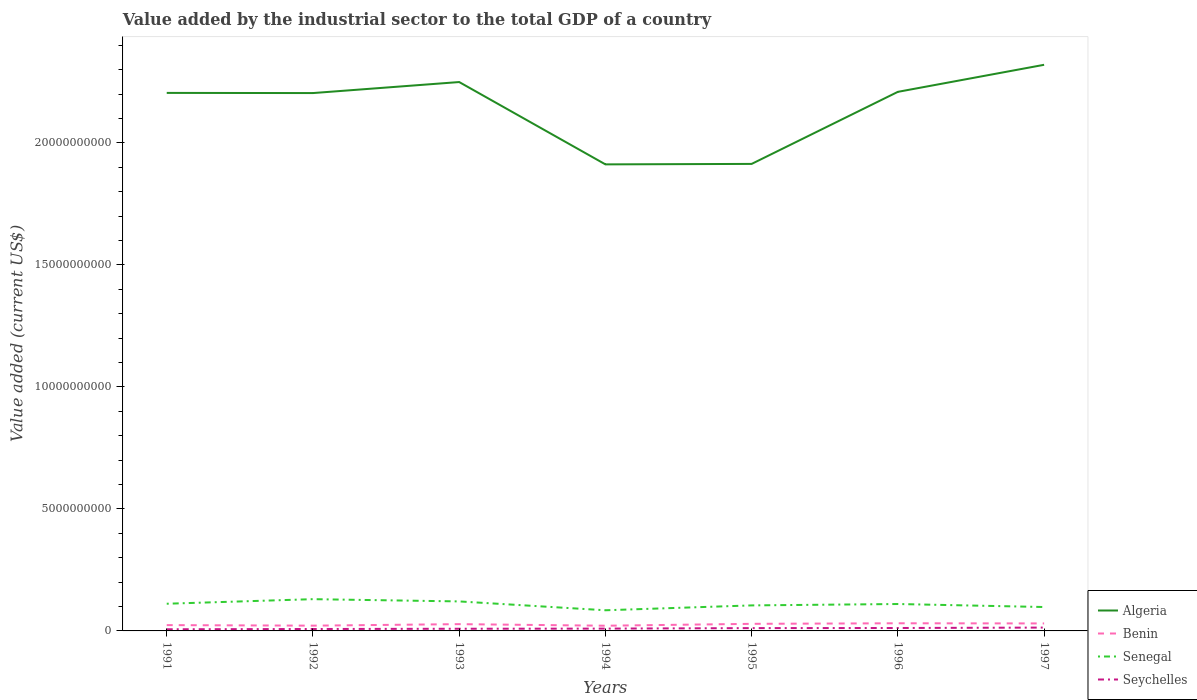Across all years, what is the maximum value added by the industrial sector to the total GDP in Seychelles?
Make the answer very short. 6.77e+07. In which year was the value added by the industrial sector to the total GDP in Senegal maximum?
Make the answer very short. 1994. What is the total value added by the industrial sector to the total GDP in Algeria in the graph?
Provide a succinct answer. 2.90e+09. What is the difference between the highest and the second highest value added by the industrial sector to the total GDP in Senegal?
Offer a terse response. 4.55e+08. What is the difference between the highest and the lowest value added by the industrial sector to the total GDP in Senegal?
Your answer should be compact. 4. What is the difference between two consecutive major ticks on the Y-axis?
Your answer should be compact. 5.00e+09. Are the values on the major ticks of Y-axis written in scientific E-notation?
Ensure brevity in your answer.  No. Does the graph contain grids?
Your answer should be compact. No. What is the title of the graph?
Your answer should be compact. Value added by the industrial sector to the total GDP of a country. What is the label or title of the X-axis?
Make the answer very short. Years. What is the label or title of the Y-axis?
Your answer should be compact. Value added (current US$). What is the Value added (current US$) of Algeria in 1991?
Your answer should be compact. 2.20e+1. What is the Value added (current US$) of Benin in 1991?
Give a very brief answer. 2.38e+08. What is the Value added (current US$) of Senegal in 1991?
Your answer should be compact. 1.11e+09. What is the Value added (current US$) of Seychelles in 1991?
Give a very brief answer. 6.77e+07. What is the Value added (current US$) in Algeria in 1992?
Provide a succinct answer. 2.20e+1. What is the Value added (current US$) in Benin in 1992?
Ensure brevity in your answer.  2.16e+08. What is the Value added (current US$) in Senegal in 1992?
Offer a terse response. 1.30e+09. What is the Value added (current US$) in Seychelles in 1992?
Offer a very short reply. 7.87e+07. What is the Value added (current US$) of Algeria in 1993?
Offer a very short reply. 2.25e+1. What is the Value added (current US$) in Benin in 1993?
Make the answer very short. 2.78e+08. What is the Value added (current US$) of Senegal in 1993?
Provide a short and direct response. 1.21e+09. What is the Value added (current US$) in Seychelles in 1993?
Provide a succinct answer. 8.90e+07. What is the Value added (current US$) in Algeria in 1994?
Give a very brief answer. 1.91e+1. What is the Value added (current US$) of Benin in 1994?
Your response must be concise. 2.13e+08. What is the Value added (current US$) of Senegal in 1994?
Give a very brief answer. 8.46e+08. What is the Value added (current US$) of Seychelles in 1994?
Give a very brief answer. 9.49e+07. What is the Value added (current US$) of Algeria in 1995?
Keep it short and to the point. 1.91e+1. What is the Value added (current US$) of Benin in 1995?
Provide a short and direct response. 2.91e+08. What is the Value added (current US$) in Senegal in 1995?
Provide a short and direct response. 1.05e+09. What is the Value added (current US$) in Seychelles in 1995?
Your answer should be compact. 1.15e+08. What is the Value added (current US$) in Algeria in 1996?
Offer a terse response. 2.21e+1. What is the Value added (current US$) of Benin in 1996?
Give a very brief answer. 3.13e+08. What is the Value added (current US$) of Senegal in 1996?
Your answer should be compact. 1.10e+09. What is the Value added (current US$) in Seychelles in 1996?
Your answer should be compact. 1.19e+08. What is the Value added (current US$) of Algeria in 1997?
Offer a terse response. 2.32e+1. What is the Value added (current US$) of Benin in 1997?
Your answer should be very brief. 3.07e+08. What is the Value added (current US$) in Senegal in 1997?
Ensure brevity in your answer.  9.79e+08. What is the Value added (current US$) of Seychelles in 1997?
Keep it short and to the point. 1.37e+08. Across all years, what is the maximum Value added (current US$) in Algeria?
Your answer should be very brief. 2.32e+1. Across all years, what is the maximum Value added (current US$) in Benin?
Provide a succinct answer. 3.13e+08. Across all years, what is the maximum Value added (current US$) of Senegal?
Your response must be concise. 1.30e+09. Across all years, what is the maximum Value added (current US$) in Seychelles?
Offer a terse response. 1.37e+08. Across all years, what is the minimum Value added (current US$) in Algeria?
Offer a terse response. 1.91e+1. Across all years, what is the minimum Value added (current US$) of Benin?
Keep it short and to the point. 2.13e+08. Across all years, what is the minimum Value added (current US$) of Senegal?
Your answer should be very brief. 8.46e+08. Across all years, what is the minimum Value added (current US$) of Seychelles?
Provide a succinct answer. 6.77e+07. What is the total Value added (current US$) in Algeria in the graph?
Ensure brevity in your answer.  1.50e+11. What is the total Value added (current US$) in Benin in the graph?
Your response must be concise. 1.86e+09. What is the total Value added (current US$) in Senegal in the graph?
Your answer should be very brief. 7.60e+09. What is the total Value added (current US$) in Seychelles in the graph?
Your answer should be very brief. 7.02e+08. What is the difference between the Value added (current US$) in Algeria in 1991 and that in 1992?
Make the answer very short. 6.81e+06. What is the difference between the Value added (current US$) of Benin in 1991 and that in 1992?
Ensure brevity in your answer.  2.23e+07. What is the difference between the Value added (current US$) in Senegal in 1991 and that in 1992?
Make the answer very short. -1.87e+08. What is the difference between the Value added (current US$) of Seychelles in 1991 and that in 1992?
Make the answer very short. -1.10e+07. What is the difference between the Value added (current US$) of Algeria in 1991 and that in 1993?
Offer a terse response. -4.45e+08. What is the difference between the Value added (current US$) in Benin in 1991 and that in 1993?
Give a very brief answer. -3.99e+07. What is the difference between the Value added (current US$) in Senegal in 1991 and that in 1993?
Provide a short and direct response. -9.46e+07. What is the difference between the Value added (current US$) of Seychelles in 1991 and that in 1993?
Provide a succinct answer. -2.13e+07. What is the difference between the Value added (current US$) in Algeria in 1991 and that in 1994?
Give a very brief answer. 2.93e+09. What is the difference between the Value added (current US$) in Benin in 1991 and that in 1994?
Your answer should be compact. 2.49e+07. What is the difference between the Value added (current US$) of Senegal in 1991 and that in 1994?
Provide a short and direct response. 2.68e+08. What is the difference between the Value added (current US$) of Seychelles in 1991 and that in 1994?
Offer a terse response. -2.72e+07. What is the difference between the Value added (current US$) in Algeria in 1991 and that in 1995?
Your answer should be very brief. 2.91e+09. What is the difference between the Value added (current US$) of Benin in 1991 and that in 1995?
Your answer should be compact. -5.25e+07. What is the difference between the Value added (current US$) of Senegal in 1991 and that in 1995?
Give a very brief answer. 6.85e+07. What is the difference between the Value added (current US$) in Seychelles in 1991 and that in 1995?
Make the answer very short. -4.75e+07. What is the difference between the Value added (current US$) of Algeria in 1991 and that in 1996?
Your answer should be compact. -4.33e+07. What is the difference between the Value added (current US$) of Benin in 1991 and that in 1996?
Offer a very short reply. -7.52e+07. What is the difference between the Value added (current US$) of Senegal in 1991 and that in 1996?
Provide a succinct answer. 1.17e+07. What is the difference between the Value added (current US$) of Seychelles in 1991 and that in 1996?
Provide a short and direct response. -5.18e+07. What is the difference between the Value added (current US$) in Algeria in 1991 and that in 1997?
Offer a very short reply. -1.15e+09. What is the difference between the Value added (current US$) of Benin in 1991 and that in 1997?
Offer a terse response. -6.87e+07. What is the difference between the Value added (current US$) in Senegal in 1991 and that in 1997?
Your answer should be compact. 1.35e+08. What is the difference between the Value added (current US$) in Seychelles in 1991 and that in 1997?
Your answer should be compact. -6.94e+07. What is the difference between the Value added (current US$) of Algeria in 1992 and that in 1993?
Keep it short and to the point. -4.51e+08. What is the difference between the Value added (current US$) in Benin in 1992 and that in 1993?
Make the answer very short. -6.21e+07. What is the difference between the Value added (current US$) in Senegal in 1992 and that in 1993?
Give a very brief answer. 9.23e+07. What is the difference between the Value added (current US$) of Seychelles in 1992 and that in 1993?
Offer a terse response. -1.03e+07. What is the difference between the Value added (current US$) of Algeria in 1992 and that in 1994?
Your response must be concise. 2.92e+09. What is the difference between the Value added (current US$) in Benin in 1992 and that in 1994?
Offer a terse response. 2.62e+06. What is the difference between the Value added (current US$) of Senegal in 1992 and that in 1994?
Your response must be concise. 4.55e+08. What is the difference between the Value added (current US$) of Seychelles in 1992 and that in 1994?
Make the answer very short. -1.62e+07. What is the difference between the Value added (current US$) of Algeria in 1992 and that in 1995?
Your response must be concise. 2.90e+09. What is the difference between the Value added (current US$) in Benin in 1992 and that in 1995?
Provide a succinct answer. -7.48e+07. What is the difference between the Value added (current US$) of Senegal in 1992 and that in 1995?
Provide a succinct answer. 2.55e+08. What is the difference between the Value added (current US$) in Seychelles in 1992 and that in 1995?
Your answer should be compact. -3.65e+07. What is the difference between the Value added (current US$) of Algeria in 1992 and that in 1996?
Provide a short and direct response. -5.01e+07. What is the difference between the Value added (current US$) in Benin in 1992 and that in 1996?
Give a very brief answer. -9.75e+07. What is the difference between the Value added (current US$) in Senegal in 1992 and that in 1996?
Your answer should be compact. 1.99e+08. What is the difference between the Value added (current US$) of Seychelles in 1992 and that in 1996?
Ensure brevity in your answer.  -4.08e+07. What is the difference between the Value added (current US$) of Algeria in 1992 and that in 1997?
Your answer should be compact. -1.16e+09. What is the difference between the Value added (current US$) in Benin in 1992 and that in 1997?
Your answer should be compact. -9.09e+07. What is the difference between the Value added (current US$) of Senegal in 1992 and that in 1997?
Give a very brief answer. 3.22e+08. What is the difference between the Value added (current US$) in Seychelles in 1992 and that in 1997?
Offer a very short reply. -5.84e+07. What is the difference between the Value added (current US$) in Algeria in 1993 and that in 1994?
Your response must be concise. 3.37e+09. What is the difference between the Value added (current US$) of Benin in 1993 and that in 1994?
Offer a terse response. 6.47e+07. What is the difference between the Value added (current US$) of Senegal in 1993 and that in 1994?
Offer a very short reply. 3.63e+08. What is the difference between the Value added (current US$) in Seychelles in 1993 and that in 1994?
Give a very brief answer. -5.85e+06. What is the difference between the Value added (current US$) of Algeria in 1993 and that in 1995?
Make the answer very short. 3.35e+09. What is the difference between the Value added (current US$) of Benin in 1993 and that in 1995?
Your answer should be very brief. -1.27e+07. What is the difference between the Value added (current US$) in Senegal in 1993 and that in 1995?
Keep it short and to the point. 1.63e+08. What is the difference between the Value added (current US$) in Seychelles in 1993 and that in 1995?
Offer a terse response. -2.62e+07. What is the difference between the Value added (current US$) in Algeria in 1993 and that in 1996?
Your answer should be very brief. 4.01e+08. What is the difference between the Value added (current US$) of Benin in 1993 and that in 1996?
Make the answer very short. -3.54e+07. What is the difference between the Value added (current US$) of Senegal in 1993 and that in 1996?
Give a very brief answer. 1.06e+08. What is the difference between the Value added (current US$) of Seychelles in 1993 and that in 1996?
Offer a terse response. -3.04e+07. What is the difference between the Value added (current US$) of Algeria in 1993 and that in 1997?
Provide a short and direct response. -7.07e+08. What is the difference between the Value added (current US$) in Benin in 1993 and that in 1997?
Offer a terse response. -2.88e+07. What is the difference between the Value added (current US$) of Senegal in 1993 and that in 1997?
Ensure brevity in your answer.  2.30e+08. What is the difference between the Value added (current US$) of Seychelles in 1993 and that in 1997?
Your answer should be very brief. -4.80e+07. What is the difference between the Value added (current US$) in Algeria in 1994 and that in 1995?
Keep it short and to the point. -1.93e+07. What is the difference between the Value added (current US$) of Benin in 1994 and that in 1995?
Ensure brevity in your answer.  -7.74e+07. What is the difference between the Value added (current US$) in Senegal in 1994 and that in 1995?
Your response must be concise. -1.99e+08. What is the difference between the Value added (current US$) in Seychelles in 1994 and that in 1995?
Offer a very short reply. -2.03e+07. What is the difference between the Value added (current US$) of Algeria in 1994 and that in 1996?
Make the answer very short. -2.97e+09. What is the difference between the Value added (current US$) of Benin in 1994 and that in 1996?
Offer a very short reply. -1.00e+08. What is the difference between the Value added (current US$) of Senegal in 1994 and that in 1996?
Give a very brief answer. -2.56e+08. What is the difference between the Value added (current US$) in Seychelles in 1994 and that in 1996?
Your response must be concise. -2.46e+07. What is the difference between the Value added (current US$) of Algeria in 1994 and that in 1997?
Provide a short and direct response. -4.08e+09. What is the difference between the Value added (current US$) in Benin in 1994 and that in 1997?
Ensure brevity in your answer.  -9.35e+07. What is the difference between the Value added (current US$) of Senegal in 1994 and that in 1997?
Keep it short and to the point. -1.33e+08. What is the difference between the Value added (current US$) of Seychelles in 1994 and that in 1997?
Your answer should be compact. -4.22e+07. What is the difference between the Value added (current US$) of Algeria in 1995 and that in 1996?
Your response must be concise. -2.95e+09. What is the difference between the Value added (current US$) of Benin in 1995 and that in 1996?
Offer a terse response. -2.27e+07. What is the difference between the Value added (current US$) of Senegal in 1995 and that in 1996?
Give a very brief answer. -5.68e+07. What is the difference between the Value added (current US$) of Seychelles in 1995 and that in 1996?
Make the answer very short. -4.27e+06. What is the difference between the Value added (current US$) of Algeria in 1995 and that in 1997?
Give a very brief answer. -4.06e+09. What is the difference between the Value added (current US$) of Benin in 1995 and that in 1997?
Your answer should be very brief. -1.61e+07. What is the difference between the Value added (current US$) of Senegal in 1995 and that in 1997?
Your response must be concise. 6.67e+07. What is the difference between the Value added (current US$) in Seychelles in 1995 and that in 1997?
Offer a terse response. -2.19e+07. What is the difference between the Value added (current US$) of Algeria in 1996 and that in 1997?
Your answer should be very brief. -1.11e+09. What is the difference between the Value added (current US$) of Benin in 1996 and that in 1997?
Offer a very short reply. 6.56e+06. What is the difference between the Value added (current US$) in Senegal in 1996 and that in 1997?
Give a very brief answer. 1.23e+08. What is the difference between the Value added (current US$) of Seychelles in 1996 and that in 1997?
Provide a short and direct response. -1.76e+07. What is the difference between the Value added (current US$) in Algeria in 1991 and the Value added (current US$) in Benin in 1992?
Offer a very short reply. 2.18e+1. What is the difference between the Value added (current US$) of Algeria in 1991 and the Value added (current US$) of Senegal in 1992?
Ensure brevity in your answer.  2.07e+1. What is the difference between the Value added (current US$) in Algeria in 1991 and the Value added (current US$) in Seychelles in 1992?
Make the answer very short. 2.20e+1. What is the difference between the Value added (current US$) in Benin in 1991 and the Value added (current US$) in Senegal in 1992?
Give a very brief answer. -1.06e+09. What is the difference between the Value added (current US$) of Benin in 1991 and the Value added (current US$) of Seychelles in 1992?
Provide a succinct answer. 1.59e+08. What is the difference between the Value added (current US$) of Senegal in 1991 and the Value added (current US$) of Seychelles in 1992?
Provide a succinct answer. 1.04e+09. What is the difference between the Value added (current US$) in Algeria in 1991 and the Value added (current US$) in Benin in 1993?
Your answer should be compact. 2.18e+1. What is the difference between the Value added (current US$) of Algeria in 1991 and the Value added (current US$) of Senegal in 1993?
Keep it short and to the point. 2.08e+1. What is the difference between the Value added (current US$) of Algeria in 1991 and the Value added (current US$) of Seychelles in 1993?
Ensure brevity in your answer.  2.20e+1. What is the difference between the Value added (current US$) of Benin in 1991 and the Value added (current US$) of Senegal in 1993?
Your answer should be compact. -9.71e+08. What is the difference between the Value added (current US$) of Benin in 1991 and the Value added (current US$) of Seychelles in 1993?
Offer a very short reply. 1.49e+08. What is the difference between the Value added (current US$) of Senegal in 1991 and the Value added (current US$) of Seychelles in 1993?
Keep it short and to the point. 1.03e+09. What is the difference between the Value added (current US$) in Algeria in 1991 and the Value added (current US$) in Benin in 1994?
Give a very brief answer. 2.18e+1. What is the difference between the Value added (current US$) of Algeria in 1991 and the Value added (current US$) of Senegal in 1994?
Give a very brief answer. 2.12e+1. What is the difference between the Value added (current US$) of Algeria in 1991 and the Value added (current US$) of Seychelles in 1994?
Provide a short and direct response. 2.20e+1. What is the difference between the Value added (current US$) in Benin in 1991 and the Value added (current US$) in Senegal in 1994?
Your answer should be very brief. -6.08e+08. What is the difference between the Value added (current US$) in Benin in 1991 and the Value added (current US$) in Seychelles in 1994?
Provide a succinct answer. 1.43e+08. What is the difference between the Value added (current US$) of Senegal in 1991 and the Value added (current US$) of Seychelles in 1994?
Offer a terse response. 1.02e+09. What is the difference between the Value added (current US$) in Algeria in 1991 and the Value added (current US$) in Benin in 1995?
Your answer should be very brief. 2.18e+1. What is the difference between the Value added (current US$) in Algeria in 1991 and the Value added (current US$) in Senegal in 1995?
Provide a succinct answer. 2.10e+1. What is the difference between the Value added (current US$) in Algeria in 1991 and the Value added (current US$) in Seychelles in 1995?
Your answer should be compact. 2.19e+1. What is the difference between the Value added (current US$) in Benin in 1991 and the Value added (current US$) in Senegal in 1995?
Offer a very short reply. -8.08e+08. What is the difference between the Value added (current US$) of Benin in 1991 and the Value added (current US$) of Seychelles in 1995?
Provide a short and direct response. 1.23e+08. What is the difference between the Value added (current US$) in Senegal in 1991 and the Value added (current US$) in Seychelles in 1995?
Your answer should be compact. 9.99e+08. What is the difference between the Value added (current US$) of Algeria in 1991 and the Value added (current US$) of Benin in 1996?
Your answer should be very brief. 2.17e+1. What is the difference between the Value added (current US$) in Algeria in 1991 and the Value added (current US$) in Senegal in 1996?
Ensure brevity in your answer.  2.09e+1. What is the difference between the Value added (current US$) of Algeria in 1991 and the Value added (current US$) of Seychelles in 1996?
Ensure brevity in your answer.  2.19e+1. What is the difference between the Value added (current US$) of Benin in 1991 and the Value added (current US$) of Senegal in 1996?
Provide a short and direct response. -8.65e+08. What is the difference between the Value added (current US$) of Benin in 1991 and the Value added (current US$) of Seychelles in 1996?
Offer a very short reply. 1.19e+08. What is the difference between the Value added (current US$) of Senegal in 1991 and the Value added (current US$) of Seychelles in 1996?
Your answer should be very brief. 9.95e+08. What is the difference between the Value added (current US$) of Algeria in 1991 and the Value added (current US$) of Benin in 1997?
Keep it short and to the point. 2.17e+1. What is the difference between the Value added (current US$) of Algeria in 1991 and the Value added (current US$) of Senegal in 1997?
Offer a very short reply. 2.11e+1. What is the difference between the Value added (current US$) of Algeria in 1991 and the Value added (current US$) of Seychelles in 1997?
Offer a terse response. 2.19e+1. What is the difference between the Value added (current US$) of Benin in 1991 and the Value added (current US$) of Senegal in 1997?
Provide a succinct answer. -7.41e+08. What is the difference between the Value added (current US$) of Benin in 1991 and the Value added (current US$) of Seychelles in 1997?
Provide a short and direct response. 1.01e+08. What is the difference between the Value added (current US$) of Senegal in 1991 and the Value added (current US$) of Seychelles in 1997?
Offer a terse response. 9.77e+08. What is the difference between the Value added (current US$) of Algeria in 1992 and the Value added (current US$) of Benin in 1993?
Provide a short and direct response. 2.18e+1. What is the difference between the Value added (current US$) in Algeria in 1992 and the Value added (current US$) in Senegal in 1993?
Your answer should be compact. 2.08e+1. What is the difference between the Value added (current US$) of Algeria in 1992 and the Value added (current US$) of Seychelles in 1993?
Make the answer very short. 2.20e+1. What is the difference between the Value added (current US$) in Benin in 1992 and the Value added (current US$) in Senegal in 1993?
Offer a very short reply. -9.93e+08. What is the difference between the Value added (current US$) of Benin in 1992 and the Value added (current US$) of Seychelles in 1993?
Offer a very short reply. 1.27e+08. What is the difference between the Value added (current US$) of Senegal in 1992 and the Value added (current US$) of Seychelles in 1993?
Your response must be concise. 1.21e+09. What is the difference between the Value added (current US$) of Algeria in 1992 and the Value added (current US$) of Benin in 1994?
Give a very brief answer. 2.18e+1. What is the difference between the Value added (current US$) of Algeria in 1992 and the Value added (current US$) of Senegal in 1994?
Give a very brief answer. 2.12e+1. What is the difference between the Value added (current US$) of Algeria in 1992 and the Value added (current US$) of Seychelles in 1994?
Make the answer very short. 2.19e+1. What is the difference between the Value added (current US$) in Benin in 1992 and the Value added (current US$) in Senegal in 1994?
Keep it short and to the point. -6.31e+08. What is the difference between the Value added (current US$) in Benin in 1992 and the Value added (current US$) in Seychelles in 1994?
Offer a terse response. 1.21e+08. What is the difference between the Value added (current US$) of Senegal in 1992 and the Value added (current US$) of Seychelles in 1994?
Your answer should be compact. 1.21e+09. What is the difference between the Value added (current US$) of Algeria in 1992 and the Value added (current US$) of Benin in 1995?
Make the answer very short. 2.18e+1. What is the difference between the Value added (current US$) in Algeria in 1992 and the Value added (current US$) in Senegal in 1995?
Provide a short and direct response. 2.10e+1. What is the difference between the Value added (current US$) in Algeria in 1992 and the Value added (current US$) in Seychelles in 1995?
Provide a succinct answer. 2.19e+1. What is the difference between the Value added (current US$) in Benin in 1992 and the Value added (current US$) in Senegal in 1995?
Your response must be concise. -8.30e+08. What is the difference between the Value added (current US$) of Benin in 1992 and the Value added (current US$) of Seychelles in 1995?
Your answer should be compact. 1.01e+08. What is the difference between the Value added (current US$) in Senegal in 1992 and the Value added (current US$) in Seychelles in 1995?
Ensure brevity in your answer.  1.19e+09. What is the difference between the Value added (current US$) of Algeria in 1992 and the Value added (current US$) of Benin in 1996?
Offer a very short reply. 2.17e+1. What is the difference between the Value added (current US$) of Algeria in 1992 and the Value added (current US$) of Senegal in 1996?
Ensure brevity in your answer.  2.09e+1. What is the difference between the Value added (current US$) in Algeria in 1992 and the Value added (current US$) in Seychelles in 1996?
Your answer should be very brief. 2.19e+1. What is the difference between the Value added (current US$) in Benin in 1992 and the Value added (current US$) in Senegal in 1996?
Provide a succinct answer. -8.87e+08. What is the difference between the Value added (current US$) of Benin in 1992 and the Value added (current US$) of Seychelles in 1996?
Your response must be concise. 9.63e+07. What is the difference between the Value added (current US$) of Senegal in 1992 and the Value added (current US$) of Seychelles in 1996?
Make the answer very short. 1.18e+09. What is the difference between the Value added (current US$) of Algeria in 1992 and the Value added (current US$) of Benin in 1997?
Offer a terse response. 2.17e+1. What is the difference between the Value added (current US$) in Algeria in 1992 and the Value added (current US$) in Senegal in 1997?
Offer a terse response. 2.11e+1. What is the difference between the Value added (current US$) of Algeria in 1992 and the Value added (current US$) of Seychelles in 1997?
Offer a terse response. 2.19e+1. What is the difference between the Value added (current US$) in Benin in 1992 and the Value added (current US$) in Senegal in 1997?
Provide a succinct answer. -7.63e+08. What is the difference between the Value added (current US$) of Benin in 1992 and the Value added (current US$) of Seychelles in 1997?
Keep it short and to the point. 7.87e+07. What is the difference between the Value added (current US$) of Senegal in 1992 and the Value added (current US$) of Seychelles in 1997?
Make the answer very short. 1.16e+09. What is the difference between the Value added (current US$) in Algeria in 1993 and the Value added (current US$) in Benin in 1994?
Offer a very short reply. 2.23e+1. What is the difference between the Value added (current US$) in Algeria in 1993 and the Value added (current US$) in Senegal in 1994?
Provide a succinct answer. 2.16e+1. What is the difference between the Value added (current US$) in Algeria in 1993 and the Value added (current US$) in Seychelles in 1994?
Provide a succinct answer. 2.24e+1. What is the difference between the Value added (current US$) in Benin in 1993 and the Value added (current US$) in Senegal in 1994?
Your response must be concise. -5.69e+08. What is the difference between the Value added (current US$) in Benin in 1993 and the Value added (current US$) in Seychelles in 1994?
Keep it short and to the point. 1.83e+08. What is the difference between the Value added (current US$) in Senegal in 1993 and the Value added (current US$) in Seychelles in 1994?
Offer a very short reply. 1.11e+09. What is the difference between the Value added (current US$) in Algeria in 1993 and the Value added (current US$) in Benin in 1995?
Give a very brief answer. 2.22e+1. What is the difference between the Value added (current US$) of Algeria in 1993 and the Value added (current US$) of Senegal in 1995?
Offer a terse response. 2.14e+1. What is the difference between the Value added (current US$) in Algeria in 1993 and the Value added (current US$) in Seychelles in 1995?
Your answer should be compact. 2.24e+1. What is the difference between the Value added (current US$) of Benin in 1993 and the Value added (current US$) of Senegal in 1995?
Make the answer very short. -7.68e+08. What is the difference between the Value added (current US$) of Benin in 1993 and the Value added (current US$) of Seychelles in 1995?
Offer a very short reply. 1.63e+08. What is the difference between the Value added (current US$) in Senegal in 1993 and the Value added (current US$) in Seychelles in 1995?
Make the answer very short. 1.09e+09. What is the difference between the Value added (current US$) in Algeria in 1993 and the Value added (current US$) in Benin in 1996?
Keep it short and to the point. 2.22e+1. What is the difference between the Value added (current US$) in Algeria in 1993 and the Value added (current US$) in Senegal in 1996?
Offer a very short reply. 2.14e+1. What is the difference between the Value added (current US$) in Algeria in 1993 and the Value added (current US$) in Seychelles in 1996?
Give a very brief answer. 2.24e+1. What is the difference between the Value added (current US$) of Benin in 1993 and the Value added (current US$) of Senegal in 1996?
Provide a short and direct response. -8.25e+08. What is the difference between the Value added (current US$) of Benin in 1993 and the Value added (current US$) of Seychelles in 1996?
Your answer should be very brief. 1.58e+08. What is the difference between the Value added (current US$) in Senegal in 1993 and the Value added (current US$) in Seychelles in 1996?
Your response must be concise. 1.09e+09. What is the difference between the Value added (current US$) in Algeria in 1993 and the Value added (current US$) in Benin in 1997?
Your answer should be very brief. 2.22e+1. What is the difference between the Value added (current US$) of Algeria in 1993 and the Value added (current US$) of Senegal in 1997?
Your answer should be compact. 2.15e+1. What is the difference between the Value added (current US$) of Algeria in 1993 and the Value added (current US$) of Seychelles in 1997?
Keep it short and to the point. 2.24e+1. What is the difference between the Value added (current US$) in Benin in 1993 and the Value added (current US$) in Senegal in 1997?
Your answer should be very brief. -7.01e+08. What is the difference between the Value added (current US$) of Benin in 1993 and the Value added (current US$) of Seychelles in 1997?
Your answer should be compact. 1.41e+08. What is the difference between the Value added (current US$) in Senegal in 1993 and the Value added (current US$) in Seychelles in 1997?
Offer a terse response. 1.07e+09. What is the difference between the Value added (current US$) of Algeria in 1994 and the Value added (current US$) of Benin in 1995?
Your answer should be compact. 1.88e+1. What is the difference between the Value added (current US$) in Algeria in 1994 and the Value added (current US$) in Senegal in 1995?
Your response must be concise. 1.81e+1. What is the difference between the Value added (current US$) in Algeria in 1994 and the Value added (current US$) in Seychelles in 1995?
Provide a succinct answer. 1.90e+1. What is the difference between the Value added (current US$) of Benin in 1994 and the Value added (current US$) of Senegal in 1995?
Provide a short and direct response. -8.33e+08. What is the difference between the Value added (current US$) of Benin in 1994 and the Value added (current US$) of Seychelles in 1995?
Give a very brief answer. 9.79e+07. What is the difference between the Value added (current US$) of Senegal in 1994 and the Value added (current US$) of Seychelles in 1995?
Your answer should be compact. 7.31e+08. What is the difference between the Value added (current US$) of Algeria in 1994 and the Value added (current US$) of Benin in 1996?
Give a very brief answer. 1.88e+1. What is the difference between the Value added (current US$) of Algeria in 1994 and the Value added (current US$) of Senegal in 1996?
Ensure brevity in your answer.  1.80e+1. What is the difference between the Value added (current US$) in Algeria in 1994 and the Value added (current US$) in Seychelles in 1996?
Your response must be concise. 1.90e+1. What is the difference between the Value added (current US$) of Benin in 1994 and the Value added (current US$) of Senegal in 1996?
Make the answer very short. -8.90e+08. What is the difference between the Value added (current US$) of Benin in 1994 and the Value added (current US$) of Seychelles in 1996?
Your answer should be compact. 9.37e+07. What is the difference between the Value added (current US$) of Senegal in 1994 and the Value added (current US$) of Seychelles in 1996?
Offer a very short reply. 7.27e+08. What is the difference between the Value added (current US$) in Algeria in 1994 and the Value added (current US$) in Benin in 1997?
Provide a short and direct response. 1.88e+1. What is the difference between the Value added (current US$) in Algeria in 1994 and the Value added (current US$) in Senegal in 1997?
Your answer should be very brief. 1.81e+1. What is the difference between the Value added (current US$) in Algeria in 1994 and the Value added (current US$) in Seychelles in 1997?
Give a very brief answer. 1.90e+1. What is the difference between the Value added (current US$) in Benin in 1994 and the Value added (current US$) in Senegal in 1997?
Provide a short and direct response. -7.66e+08. What is the difference between the Value added (current US$) in Benin in 1994 and the Value added (current US$) in Seychelles in 1997?
Give a very brief answer. 7.61e+07. What is the difference between the Value added (current US$) of Senegal in 1994 and the Value added (current US$) of Seychelles in 1997?
Keep it short and to the point. 7.09e+08. What is the difference between the Value added (current US$) in Algeria in 1995 and the Value added (current US$) in Benin in 1996?
Your answer should be compact. 1.88e+1. What is the difference between the Value added (current US$) in Algeria in 1995 and the Value added (current US$) in Senegal in 1996?
Provide a succinct answer. 1.80e+1. What is the difference between the Value added (current US$) in Algeria in 1995 and the Value added (current US$) in Seychelles in 1996?
Provide a succinct answer. 1.90e+1. What is the difference between the Value added (current US$) in Benin in 1995 and the Value added (current US$) in Senegal in 1996?
Offer a terse response. -8.12e+08. What is the difference between the Value added (current US$) in Benin in 1995 and the Value added (current US$) in Seychelles in 1996?
Your answer should be very brief. 1.71e+08. What is the difference between the Value added (current US$) of Senegal in 1995 and the Value added (current US$) of Seychelles in 1996?
Offer a very short reply. 9.26e+08. What is the difference between the Value added (current US$) of Algeria in 1995 and the Value added (current US$) of Benin in 1997?
Your response must be concise. 1.88e+1. What is the difference between the Value added (current US$) of Algeria in 1995 and the Value added (current US$) of Senegal in 1997?
Make the answer very short. 1.82e+1. What is the difference between the Value added (current US$) of Algeria in 1995 and the Value added (current US$) of Seychelles in 1997?
Make the answer very short. 1.90e+1. What is the difference between the Value added (current US$) of Benin in 1995 and the Value added (current US$) of Senegal in 1997?
Ensure brevity in your answer.  -6.89e+08. What is the difference between the Value added (current US$) of Benin in 1995 and the Value added (current US$) of Seychelles in 1997?
Offer a very short reply. 1.53e+08. What is the difference between the Value added (current US$) of Senegal in 1995 and the Value added (current US$) of Seychelles in 1997?
Your answer should be very brief. 9.09e+08. What is the difference between the Value added (current US$) of Algeria in 1996 and the Value added (current US$) of Benin in 1997?
Keep it short and to the point. 2.18e+1. What is the difference between the Value added (current US$) in Algeria in 1996 and the Value added (current US$) in Senegal in 1997?
Offer a very short reply. 2.11e+1. What is the difference between the Value added (current US$) of Algeria in 1996 and the Value added (current US$) of Seychelles in 1997?
Provide a succinct answer. 2.20e+1. What is the difference between the Value added (current US$) of Benin in 1996 and the Value added (current US$) of Senegal in 1997?
Keep it short and to the point. -6.66e+08. What is the difference between the Value added (current US$) in Benin in 1996 and the Value added (current US$) in Seychelles in 1997?
Offer a terse response. 1.76e+08. What is the difference between the Value added (current US$) in Senegal in 1996 and the Value added (current US$) in Seychelles in 1997?
Your answer should be very brief. 9.66e+08. What is the average Value added (current US$) in Algeria per year?
Keep it short and to the point. 2.14e+1. What is the average Value added (current US$) of Benin per year?
Give a very brief answer. 2.65e+08. What is the average Value added (current US$) in Senegal per year?
Offer a very short reply. 1.09e+09. What is the average Value added (current US$) of Seychelles per year?
Ensure brevity in your answer.  1.00e+08. In the year 1991, what is the difference between the Value added (current US$) in Algeria and Value added (current US$) in Benin?
Your response must be concise. 2.18e+1. In the year 1991, what is the difference between the Value added (current US$) in Algeria and Value added (current US$) in Senegal?
Provide a short and direct response. 2.09e+1. In the year 1991, what is the difference between the Value added (current US$) of Algeria and Value added (current US$) of Seychelles?
Offer a very short reply. 2.20e+1. In the year 1991, what is the difference between the Value added (current US$) of Benin and Value added (current US$) of Senegal?
Offer a terse response. -8.76e+08. In the year 1991, what is the difference between the Value added (current US$) in Benin and Value added (current US$) in Seychelles?
Give a very brief answer. 1.70e+08. In the year 1991, what is the difference between the Value added (current US$) in Senegal and Value added (current US$) in Seychelles?
Offer a terse response. 1.05e+09. In the year 1992, what is the difference between the Value added (current US$) of Algeria and Value added (current US$) of Benin?
Keep it short and to the point. 2.18e+1. In the year 1992, what is the difference between the Value added (current US$) of Algeria and Value added (current US$) of Senegal?
Provide a short and direct response. 2.07e+1. In the year 1992, what is the difference between the Value added (current US$) of Algeria and Value added (current US$) of Seychelles?
Your answer should be very brief. 2.20e+1. In the year 1992, what is the difference between the Value added (current US$) of Benin and Value added (current US$) of Senegal?
Provide a short and direct response. -1.09e+09. In the year 1992, what is the difference between the Value added (current US$) in Benin and Value added (current US$) in Seychelles?
Provide a short and direct response. 1.37e+08. In the year 1992, what is the difference between the Value added (current US$) of Senegal and Value added (current US$) of Seychelles?
Offer a terse response. 1.22e+09. In the year 1993, what is the difference between the Value added (current US$) of Algeria and Value added (current US$) of Benin?
Make the answer very short. 2.22e+1. In the year 1993, what is the difference between the Value added (current US$) of Algeria and Value added (current US$) of Senegal?
Offer a terse response. 2.13e+1. In the year 1993, what is the difference between the Value added (current US$) of Algeria and Value added (current US$) of Seychelles?
Offer a very short reply. 2.24e+1. In the year 1993, what is the difference between the Value added (current US$) in Benin and Value added (current US$) in Senegal?
Make the answer very short. -9.31e+08. In the year 1993, what is the difference between the Value added (current US$) in Benin and Value added (current US$) in Seychelles?
Your answer should be compact. 1.89e+08. In the year 1993, what is the difference between the Value added (current US$) of Senegal and Value added (current US$) of Seychelles?
Provide a succinct answer. 1.12e+09. In the year 1994, what is the difference between the Value added (current US$) of Algeria and Value added (current US$) of Benin?
Your answer should be compact. 1.89e+1. In the year 1994, what is the difference between the Value added (current US$) in Algeria and Value added (current US$) in Senegal?
Keep it short and to the point. 1.83e+1. In the year 1994, what is the difference between the Value added (current US$) of Algeria and Value added (current US$) of Seychelles?
Your response must be concise. 1.90e+1. In the year 1994, what is the difference between the Value added (current US$) in Benin and Value added (current US$) in Senegal?
Offer a very short reply. -6.33e+08. In the year 1994, what is the difference between the Value added (current US$) in Benin and Value added (current US$) in Seychelles?
Provide a succinct answer. 1.18e+08. In the year 1994, what is the difference between the Value added (current US$) in Senegal and Value added (current US$) in Seychelles?
Offer a terse response. 7.52e+08. In the year 1995, what is the difference between the Value added (current US$) in Algeria and Value added (current US$) in Benin?
Give a very brief answer. 1.88e+1. In the year 1995, what is the difference between the Value added (current US$) in Algeria and Value added (current US$) in Senegal?
Your response must be concise. 1.81e+1. In the year 1995, what is the difference between the Value added (current US$) of Algeria and Value added (current US$) of Seychelles?
Provide a succinct answer. 1.90e+1. In the year 1995, what is the difference between the Value added (current US$) in Benin and Value added (current US$) in Senegal?
Keep it short and to the point. -7.55e+08. In the year 1995, what is the difference between the Value added (current US$) in Benin and Value added (current US$) in Seychelles?
Provide a succinct answer. 1.75e+08. In the year 1995, what is the difference between the Value added (current US$) in Senegal and Value added (current US$) in Seychelles?
Offer a very short reply. 9.31e+08. In the year 1996, what is the difference between the Value added (current US$) in Algeria and Value added (current US$) in Benin?
Your answer should be very brief. 2.18e+1. In the year 1996, what is the difference between the Value added (current US$) of Algeria and Value added (current US$) of Senegal?
Ensure brevity in your answer.  2.10e+1. In the year 1996, what is the difference between the Value added (current US$) of Algeria and Value added (current US$) of Seychelles?
Ensure brevity in your answer.  2.20e+1. In the year 1996, what is the difference between the Value added (current US$) of Benin and Value added (current US$) of Senegal?
Provide a succinct answer. -7.89e+08. In the year 1996, what is the difference between the Value added (current US$) of Benin and Value added (current US$) of Seychelles?
Provide a succinct answer. 1.94e+08. In the year 1996, what is the difference between the Value added (current US$) in Senegal and Value added (current US$) in Seychelles?
Provide a succinct answer. 9.83e+08. In the year 1997, what is the difference between the Value added (current US$) in Algeria and Value added (current US$) in Benin?
Provide a succinct answer. 2.29e+1. In the year 1997, what is the difference between the Value added (current US$) in Algeria and Value added (current US$) in Senegal?
Provide a succinct answer. 2.22e+1. In the year 1997, what is the difference between the Value added (current US$) of Algeria and Value added (current US$) of Seychelles?
Keep it short and to the point. 2.31e+1. In the year 1997, what is the difference between the Value added (current US$) of Benin and Value added (current US$) of Senegal?
Offer a terse response. -6.73e+08. In the year 1997, what is the difference between the Value added (current US$) of Benin and Value added (current US$) of Seychelles?
Your answer should be compact. 1.70e+08. In the year 1997, what is the difference between the Value added (current US$) in Senegal and Value added (current US$) in Seychelles?
Offer a very short reply. 8.42e+08. What is the ratio of the Value added (current US$) of Benin in 1991 to that in 1992?
Ensure brevity in your answer.  1.1. What is the ratio of the Value added (current US$) of Senegal in 1991 to that in 1992?
Provide a short and direct response. 0.86. What is the ratio of the Value added (current US$) of Seychelles in 1991 to that in 1992?
Your response must be concise. 0.86. What is the ratio of the Value added (current US$) of Algeria in 1991 to that in 1993?
Provide a short and direct response. 0.98. What is the ratio of the Value added (current US$) of Benin in 1991 to that in 1993?
Make the answer very short. 0.86. What is the ratio of the Value added (current US$) of Senegal in 1991 to that in 1993?
Your response must be concise. 0.92. What is the ratio of the Value added (current US$) in Seychelles in 1991 to that in 1993?
Provide a short and direct response. 0.76. What is the ratio of the Value added (current US$) of Algeria in 1991 to that in 1994?
Ensure brevity in your answer.  1.15. What is the ratio of the Value added (current US$) in Benin in 1991 to that in 1994?
Ensure brevity in your answer.  1.12. What is the ratio of the Value added (current US$) of Senegal in 1991 to that in 1994?
Make the answer very short. 1.32. What is the ratio of the Value added (current US$) in Seychelles in 1991 to that in 1994?
Provide a short and direct response. 0.71. What is the ratio of the Value added (current US$) of Algeria in 1991 to that in 1995?
Ensure brevity in your answer.  1.15. What is the ratio of the Value added (current US$) of Benin in 1991 to that in 1995?
Offer a very short reply. 0.82. What is the ratio of the Value added (current US$) of Senegal in 1991 to that in 1995?
Make the answer very short. 1.07. What is the ratio of the Value added (current US$) of Seychelles in 1991 to that in 1995?
Give a very brief answer. 0.59. What is the ratio of the Value added (current US$) in Benin in 1991 to that in 1996?
Provide a succinct answer. 0.76. What is the ratio of the Value added (current US$) in Senegal in 1991 to that in 1996?
Your response must be concise. 1.01. What is the ratio of the Value added (current US$) of Seychelles in 1991 to that in 1996?
Your response must be concise. 0.57. What is the ratio of the Value added (current US$) of Algeria in 1991 to that in 1997?
Provide a short and direct response. 0.95. What is the ratio of the Value added (current US$) in Benin in 1991 to that in 1997?
Make the answer very short. 0.78. What is the ratio of the Value added (current US$) in Senegal in 1991 to that in 1997?
Make the answer very short. 1.14. What is the ratio of the Value added (current US$) in Seychelles in 1991 to that in 1997?
Give a very brief answer. 0.49. What is the ratio of the Value added (current US$) in Algeria in 1992 to that in 1993?
Your answer should be very brief. 0.98. What is the ratio of the Value added (current US$) in Benin in 1992 to that in 1993?
Make the answer very short. 0.78. What is the ratio of the Value added (current US$) of Senegal in 1992 to that in 1993?
Offer a terse response. 1.08. What is the ratio of the Value added (current US$) in Seychelles in 1992 to that in 1993?
Offer a terse response. 0.88. What is the ratio of the Value added (current US$) of Algeria in 1992 to that in 1994?
Give a very brief answer. 1.15. What is the ratio of the Value added (current US$) in Benin in 1992 to that in 1994?
Provide a short and direct response. 1.01. What is the ratio of the Value added (current US$) of Senegal in 1992 to that in 1994?
Keep it short and to the point. 1.54. What is the ratio of the Value added (current US$) in Seychelles in 1992 to that in 1994?
Your response must be concise. 0.83. What is the ratio of the Value added (current US$) of Algeria in 1992 to that in 1995?
Your answer should be compact. 1.15. What is the ratio of the Value added (current US$) in Benin in 1992 to that in 1995?
Make the answer very short. 0.74. What is the ratio of the Value added (current US$) of Senegal in 1992 to that in 1995?
Your answer should be very brief. 1.24. What is the ratio of the Value added (current US$) of Seychelles in 1992 to that in 1995?
Offer a terse response. 0.68. What is the ratio of the Value added (current US$) of Benin in 1992 to that in 1996?
Provide a short and direct response. 0.69. What is the ratio of the Value added (current US$) in Senegal in 1992 to that in 1996?
Your response must be concise. 1.18. What is the ratio of the Value added (current US$) of Seychelles in 1992 to that in 1996?
Your answer should be very brief. 0.66. What is the ratio of the Value added (current US$) of Algeria in 1992 to that in 1997?
Make the answer very short. 0.95. What is the ratio of the Value added (current US$) in Benin in 1992 to that in 1997?
Give a very brief answer. 0.7. What is the ratio of the Value added (current US$) of Senegal in 1992 to that in 1997?
Your response must be concise. 1.33. What is the ratio of the Value added (current US$) in Seychelles in 1992 to that in 1997?
Offer a terse response. 0.57. What is the ratio of the Value added (current US$) in Algeria in 1993 to that in 1994?
Provide a succinct answer. 1.18. What is the ratio of the Value added (current US$) of Benin in 1993 to that in 1994?
Make the answer very short. 1.3. What is the ratio of the Value added (current US$) in Senegal in 1993 to that in 1994?
Your response must be concise. 1.43. What is the ratio of the Value added (current US$) of Seychelles in 1993 to that in 1994?
Provide a succinct answer. 0.94. What is the ratio of the Value added (current US$) in Algeria in 1993 to that in 1995?
Your response must be concise. 1.18. What is the ratio of the Value added (current US$) in Benin in 1993 to that in 1995?
Keep it short and to the point. 0.96. What is the ratio of the Value added (current US$) in Senegal in 1993 to that in 1995?
Your answer should be very brief. 1.16. What is the ratio of the Value added (current US$) in Seychelles in 1993 to that in 1995?
Your answer should be compact. 0.77. What is the ratio of the Value added (current US$) in Algeria in 1993 to that in 1996?
Provide a short and direct response. 1.02. What is the ratio of the Value added (current US$) in Benin in 1993 to that in 1996?
Your response must be concise. 0.89. What is the ratio of the Value added (current US$) of Senegal in 1993 to that in 1996?
Give a very brief answer. 1.1. What is the ratio of the Value added (current US$) in Seychelles in 1993 to that in 1996?
Provide a succinct answer. 0.75. What is the ratio of the Value added (current US$) of Algeria in 1993 to that in 1997?
Give a very brief answer. 0.97. What is the ratio of the Value added (current US$) of Benin in 1993 to that in 1997?
Give a very brief answer. 0.91. What is the ratio of the Value added (current US$) in Senegal in 1993 to that in 1997?
Your answer should be very brief. 1.23. What is the ratio of the Value added (current US$) of Seychelles in 1993 to that in 1997?
Your answer should be very brief. 0.65. What is the ratio of the Value added (current US$) in Algeria in 1994 to that in 1995?
Your response must be concise. 1. What is the ratio of the Value added (current US$) in Benin in 1994 to that in 1995?
Your answer should be very brief. 0.73. What is the ratio of the Value added (current US$) in Senegal in 1994 to that in 1995?
Ensure brevity in your answer.  0.81. What is the ratio of the Value added (current US$) of Seychelles in 1994 to that in 1995?
Offer a very short reply. 0.82. What is the ratio of the Value added (current US$) of Algeria in 1994 to that in 1996?
Your response must be concise. 0.87. What is the ratio of the Value added (current US$) in Benin in 1994 to that in 1996?
Offer a very short reply. 0.68. What is the ratio of the Value added (current US$) in Senegal in 1994 to that in 1996?
Make the answer very short. 0.77. What is the ratio of the Value added (current US$) in Seychelles in 1994 to that in 1996?
Offer a terse response. 0.79. What is the ratio of the Value added (current US$) of Algeria in 1994 to that in 1997?
Keep it short and to the point. 0.82. What is the ratio of the Value added (current US$) of Benin in 1994 to that in 1997?
Your response must be concise. 0.69. What is the ratio of the Value added (current US$) of Senegal in 1994 to that in 1997?
Provide a short and direct response. 0.86. What is the ratio of the Value added (current US$) of Seychelles in 1994 to that in 1997?
Make the answer very short. 0.69. What is the ratio of the Value added (current US$) in Algeria in 1995 to that in 1996?
Your answer should be compact. 0.87. What is the ratio of the Value added (current US$) of Benin in 1995 to that in 1996?
Offer a very short reply. 0.93. What is the ratio of the Value added (current US$) of Senegal in 1995 to that in 1996?
Your response must be concise. 0.95. What is the ratio of the Value added (current US$) in Seychelles in 1995 to that in 1996?
Ensure brevity in your answer.  0.96. What is the ratio of the Value added (current US$) of Algeria in 1995 to that in 1997?
Give a very brief answer. 0.82. What is the ratio of the Value added (current US$) of Senegal in 1995 to that in 1997?
Offer a very short reply. 1.07. What is the ratio of the Value added (current US$) of Seychelles in 1995 to that in 1997?
Provide a short and direct response. 0.84. What is the ratio of the Value added (current US$) in Algeria in 1996 to that in 1997?
Make the answer very short. 0.95. What is the ratio of the Value added (current US$) of Benin in 1996 to that in 1997?
Provide a short and direct response. 1.02. What is the ratio of the Value added (current US$) of Senegal in 1996 to that in 1997?
Provide a short and direct response. 1.13. What is the ratio of the Value added (current US$) in Seychelles in 1996 to that in 1997?
Your response must be concise. 0.87. What is the difference between the highest and the second highest Value added (current US$) of Algeria?
Your answer should be compact. 7.07e+08. What is the difference between the highest and the second highest Value added (current US$) in Benin?
Your response must be concise. 6.56e+06. What is the difference between the highest and the second highest Value added (current US$) of Senegal?
Provide a short and direct response. 9.23e+07. What is the difference between the highest and the second highest Value added (current US$) in Seychelles?
Offer a very short reply. 1.76e+07. What is the difference between the highest and the lowest Value added (current US$) of Algeria?
Make the answer very short. 4.08e+09. What is the difference between the highest and the lowest Value added (current US$) of Benin?
Provide a short and direct response. 1.00e+08. What is the difference between the highest and the lowest Value added (current US$) in Senegal?
Provide a short and direct response. 4.55e+08. What is the difference between the highest and the lowest Value added (current US$) of Seychelles?
Provide a short and direct response. 6.94e+07. 